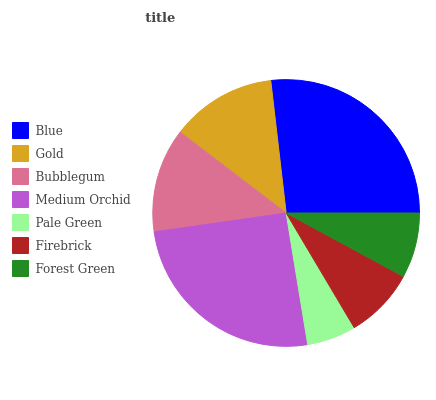Is Pale Green the minimum?
Answer yes or no. Yes. Is Blue the maximum?
Answer yes or no. Yes. Is Gold the minimum?
Answer yes or no. No. Is Gold the maximum?
Answer yes or no. No. Is Blue greater than Gold?
Answer yes or no. Yes. Is Gold less than Blue?
Answer yes or no. Yes. Is Gold greater than Blue?
Answer yes or no. No. Is Blue less than Gold?
Answer yes or no. No. Is Bubblegum the high median?
Answer yes or no. Yes. Is Bubblegum the low median?
Answer yes or no. Yes. Is Gold the high median?
Answer yes or no. No. Is Gold the low median?
Answer yes or no. No. 